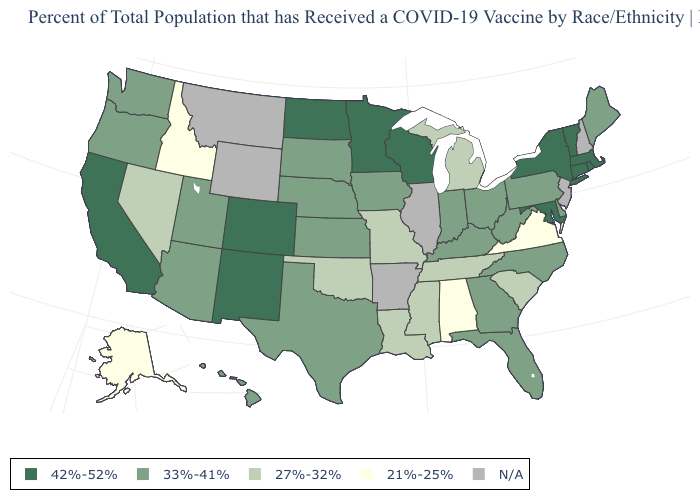Name the states that have a value in the range 21%-25%?
Keep it brief. Alabama, Alaska, Idaho, Virginia. Name the states that have a value in the range 21%-25%?
Be succinct. Alabama, Alaska, Idaho, Virginia. What is the value of Connecticut?
Quick response, please. 42%-52%. Does Maine have the highest value in the USA?
Be succinct. No. Name the states that have a value in the range 21%-25%?
Be succinct. Alabama, Alaska, Idaho, Virginia. Among the states that border Florida , does Alabama have the highest value?
Short answer required. No. Is the legend a continuous bar?
Short answer required. No. Among the states that border Illinois , which have the lowest value?
Answer briefly. Missouri. Name the states that have a value in the range N/A?
Write a very short answer. Arkansas, Illinois, Montana, New Hampshire, New Jersey, Wyoming. What is the value of Georgia?
Concise answer only. 33%-41%. Name the states that have a value in the range N/A?
Quick response, please. Arkansas, Illinois, Montana, New Hampshire, New Jersey, Wyoming. Among the states that border Florida , does Georgia have the highest value?
Give a very brief answer. Yes. Which states have the highest value in the USA?
Quick response, please. California, Colorado, Connecticut, Maryland, Massachusetts, Minnesota, New Mexico, New York, North Dakota, Rhode Island, Vermont, Wisconsin. What is the value of Nebraska?
Keep it brief. 33%-41%. What is the value of California?
Be succinct. 42%-52%. 